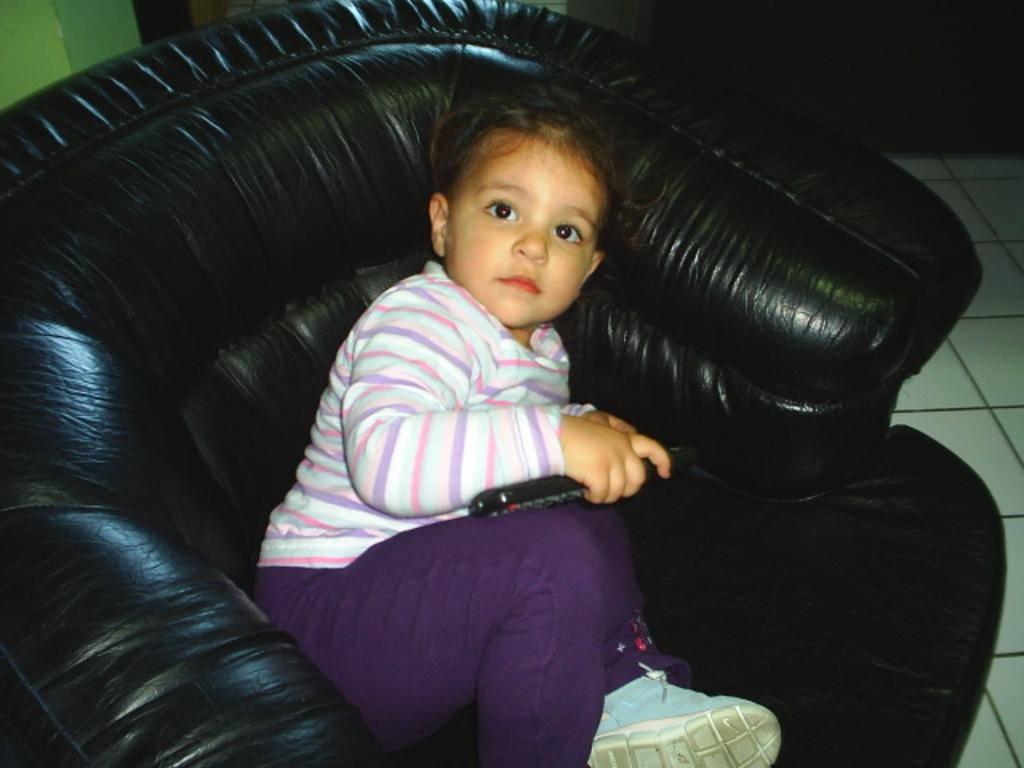What is the main subject of the picture? The main subject of the picture is a baby. What is the baby holding in the picture? The baby is holding a remote control. What type of footwear is the baby wearing? The baby is wearing shoes. Where is the baby sitting in the picture? The baby is sitting on a black sofa. What type of location does the picture appear to be set in? The setting appears to be a house. What type of coil is visible in the picture? There is no coil visible in the picture; the main subject is a baby holding a remote control while sitting on a black sofa. What type of mist can be seen surrounding the baby in the picture? There is no mist present in the picture; the setting appears to be a clear and well-lit room. 